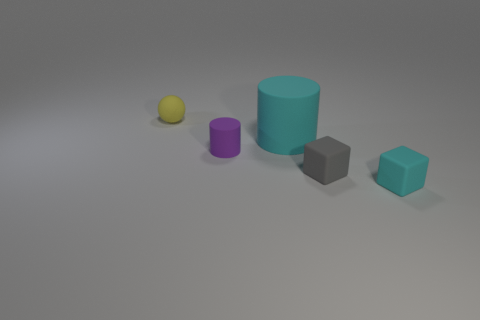Is the number of cyan objects that are behind the small purple rubber thing greater than the number of small cyan matte blocks behind the big cyan cylinder?
Give a very brief answer. Yes. Is the color of the rubber cylinder that is in front of the large cylinder the same as the big object?
Offer a terse response. No. Are there any other things that are the same color as the small rubber cylinder?
Offer a terse response. No. Are there more small cyan rubber things to the left of the yellow matte thing than big cylinders?
Your answer should be very brief. No. Is the yellow thing the same size as the cyan rubber cube?
Keep it short and to the point. Yes. There is another object that is the same shape as the tiny cyan rubber object; what material is it?
Your response must be concise. Rubber. How many red objects are cylinders or tiny rubber cylinders?
Give a very brief answer. 0. Are there more purple rubber cylinders than matte things?
Make the answer very short. No. Is the shape of the cyan thing that is on the right side of the small gray rubber cube the same as  the small yellow thing?
Make the answer very short. No. What number of matte things are both right of the cyan matte cylinder and to the left of the tiny cyan cube?
Your answer should be very brief. 1. 